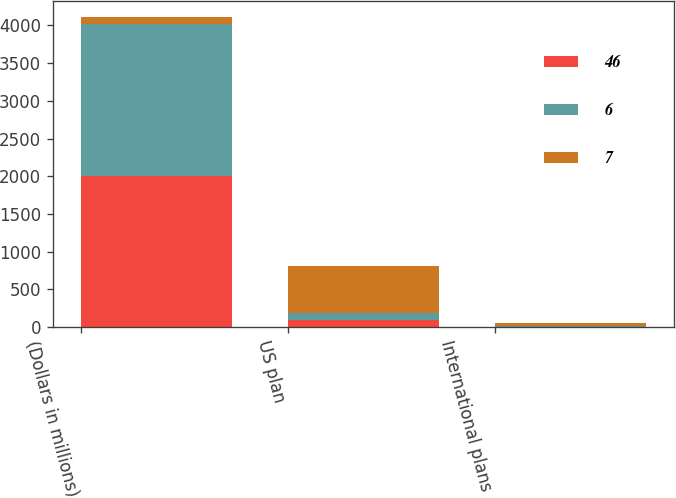Convert chart to OTSL. <chart><loc_0><loc_0><loc_500><loc_500><stacked_bar_chart><ecel><fcel>(Dollars in millions)<fcel>US plan<fcel>International plans<nl><fcel>46<fcel>2008<fcel>90<fcel>6<nl><fcel>6<fcel>2011<fcel>99<fcel>7<nl><fcel>7<fcel>94.5<fcel>627<fcel>46<nl></chart> 